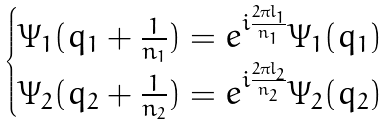<formula> <loc_0><loc_0><loc_500><loc_500>\begin{cases} \Psi _ { 1 } ( q _ { 1 } + \frac { 1 } { n _ { 1 } } ) = e ^ { i \frac { 2 \pi l _ { 1 } } { n _ { 1 } } } \Psi _ { 1 } ( q _ { 1 } ) \\ \Psi _ { 2 } ( q _ { 2 } + \frac { 1 } { n _ { 2 } } ) = e ^ { i \frac { 2 \pi l _ { 2 } } { n _ { 2 } } } \Psi _ { 2 } ( q _ { 2 } ) \end{cases}</formula> 